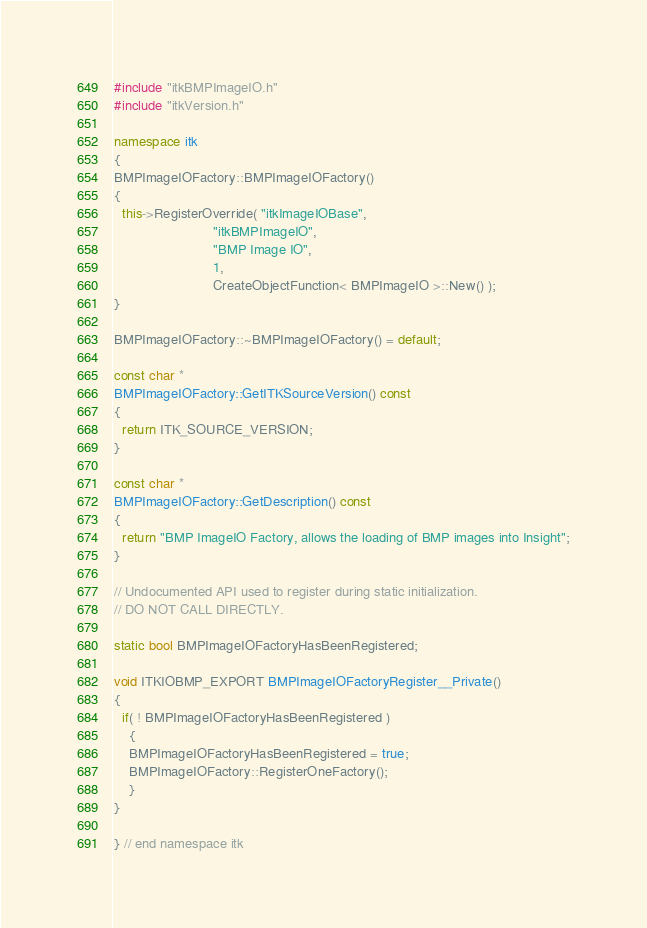<code> <loc_0><loc_0><loc_500><loc_500><_C++_>#include "itkBMPImageIO.h"
#include "itkVersion.h"

namespace itk
{
BMPImageIOFactory::BMPImageIOFactory()
{
  this->RegisterOverride( "itkImageIOBase",
                          "itkBMPImageIO",
                          "BMP Image IO",
                          1,
                          CreateObjectFunction< BMPImageIO >::New() );
}

BMPImageIOFactory::~BMPImageIOFactory() = default;

const char *
BMPImageIOFactory::GetITKSourceVersion() const
{
  return ITK_SOURCE_VERSION;
}

const char *
BMPImageIOFactory::GetDescription() const
{
  return "BMP ImageIO Factory, allows the loading of BMP images into Insight";
}

// Undocumented API used to register during static initialization.
// DO NOT CALL DIRECTLY.

static bool BMPImageIOFactoryHasBeenRegistered;

void ITKIOBMP_EXPORT BMPImageIOFactoryRegister__Private()
{
  if( ! BMPImageIOFactoryHasBeenRegistered )
    {
    BMPImageIOFactoryHasBeenRegistered = true;
    BMPImageIOFactory::RegisterOneFactory();
    }
}

} // end namespace itk
</code> 